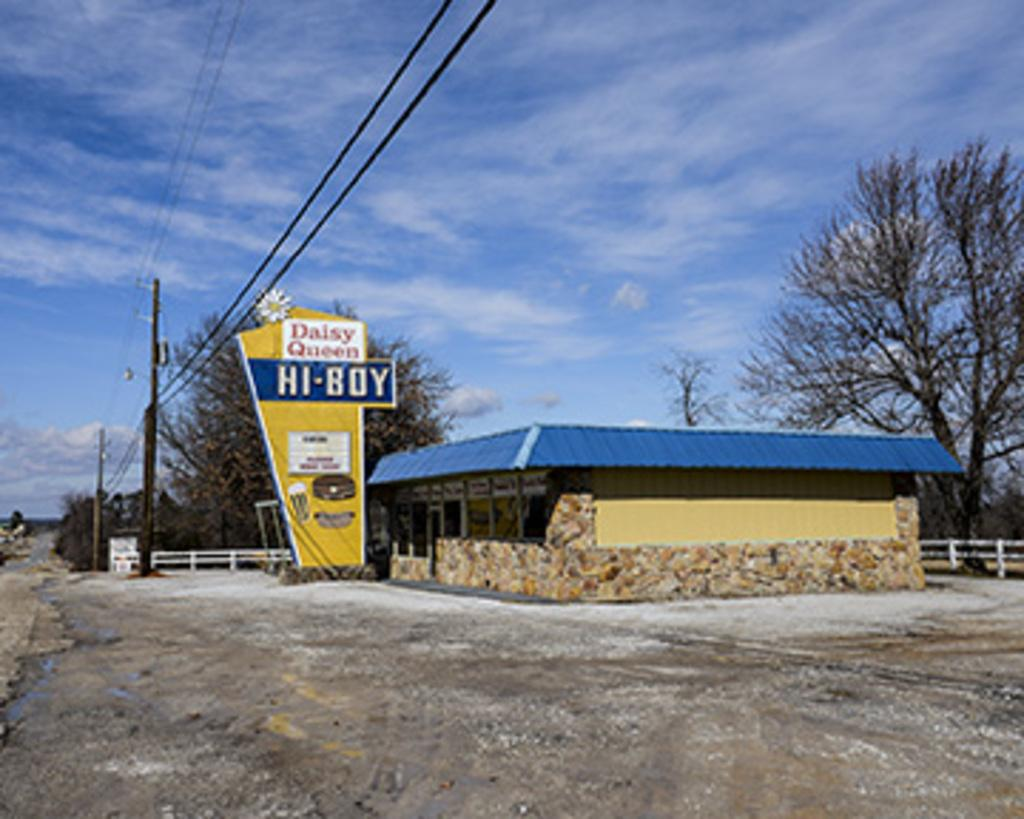What structures can be seen in the image? There are poles, a hoarding, a house, and a fence in the image. What type of natural elements are present in the image? There are trees in the image. What is visible in the background of the image? The sky is visible in the background of the image, with clouds present. What type of mouth can be seen on the house in the image? There is no mouth present on the house in the image. How many wheels can be seen on the trees in the image? There are no wheels present on the trees in the image. 